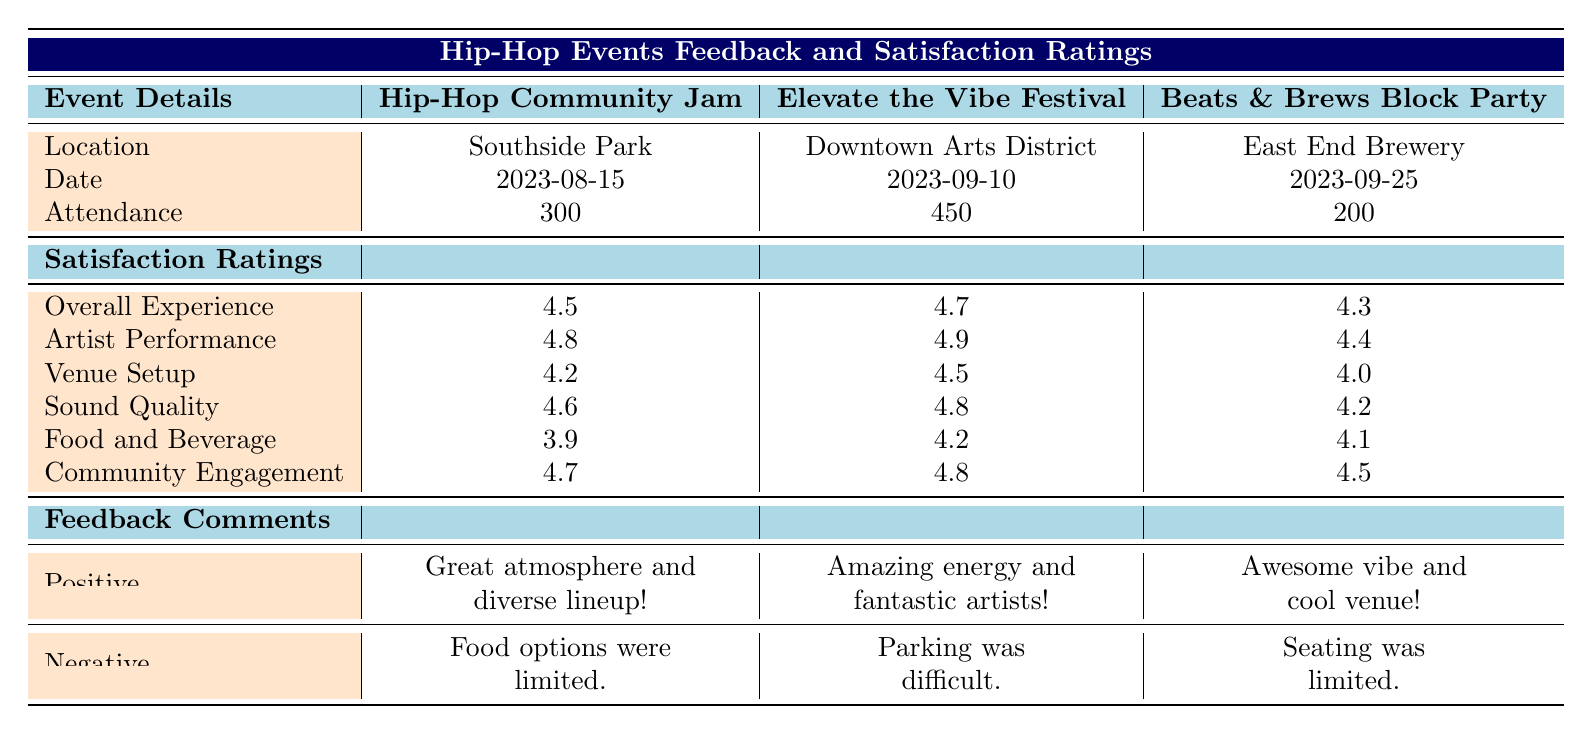What is the Overall Experience rating for the Elevate the Vibe Festival? The Overall Experience rating for the Elevate the Vibe Festival is listed under Satisfaction Ratings in the table. It shows a rating of 4.7.
Answer: 4.7 Which event had the highest Artist Performance rating? By comparing the Artist Performance ratings across the three events, the Elevate the Vibe Festival has the highest score of 4.9.
Answer: Elevate the Vibe Festival What is the average Sound Quality rating across all three events? To find the average Sound Quality rating, sum the ratings for each event (4.6 + 4.8 + 4.2 = 13.6) and divide by three, resulting in an average of 13.6/3 = 4.53.
Answer: 4.53 Was the Food and Beverage rating higher than 4 for all events? By checking the Food and Beverage ratings, the Hip-Hop Community Jam has a rating of 3.9, which is below 4. Hence, not all events had a rating higher than 4.
Answer: No What is the difference in Community Engagement ratings between the highest and lowest rated events? The highest Community Engagement rating is 4.8 for the Elevate the Vibe Festival and the lowest is 4.5 for Beats & Brews Block Party. The difference is 4.8 - 4.5 = 0.3.
Answer: 0.3 How many attendees did the Beats & Brews Block Party attract? The attendance figure for the Beats & Brews Block Party can be found in the Event Details section, where it shows an attendance of 200.
Answer: 200 Which event had the most positive comments and what was one highlighted comment? Cross-referencing the Positive Comments section, Elevate the Vibe Festival has two positive comments listed, which are more than the others. One highlighted comment is "Amazing energy and fantastic artists!"
Answer: Elevate the Vibe Festival; "Amazing energy and fantastic artists!" What would you say about the overall reception of the Food and Beverage options across the events? By looking at the Food and Beverage ratings, they range from 3.9 to 4.2. This indicates mixed feedback, with the lowest score at Hip-Hop Community Jam suggesting some attendees were not satisfied with these options.
Answer: Mixed feedback Which event had the least attendance and what impact might that have on its ratings? The Beats & Brews Block Party had the least attendance, attracting 200 attendees. Lower attendance could imply less feedback on the event, potentially affecting the reliability of its ratings.
Answer: Beats & Brews Block Party; it may affect reliability of ratings Which event had the highest score for Community Engagement? The Community Engagement rating for the Elevate the Vibe Festival is 4.8, which is the highest among the three events.
Answer: Elevate the Vibe Festival 